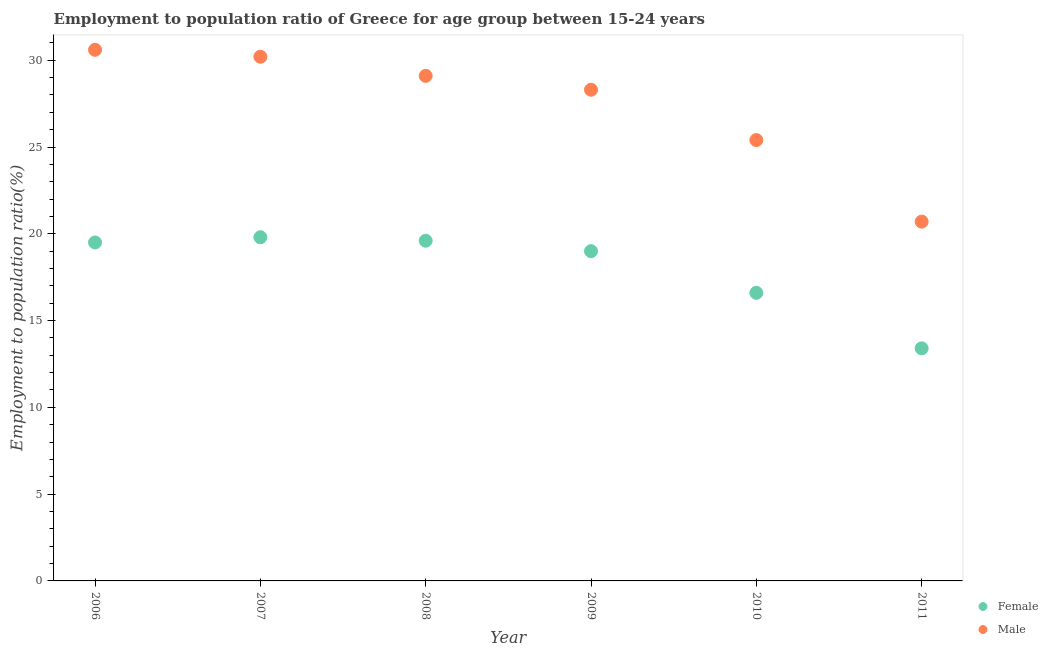What is the employment to population ratio(female) in 2011?
Your answer should be compact. 13.4. Across all years, what is the maximum employment to population ratio(female)?
Give a very brief answer. 19.8. Across all years, what is the minimum employment to population ratio(female)?
Your answer should be very brief. 13.4. What is the total employment to population ratio(female) in the graph?
Provide a short and direct response. 107.9. What is the difference between the employment to population ratio(female) in 2007 and the employment to population ratio(male) in 2010?
Provide a short and direct response. -5.6. What is the average employment to population ratio(female) per year?
Keep it short and to the point. 17.98. In the year 2010, what is the difference between the employment to population ratio(female) and employment to population ratio(male)?
Offer a terse response. -8.8. What is the ratio of the employment to population ratio(male) in 2008 to that in 2011?
Provide a short and direct response. 1.41. Is the difference between the employment to population ratio(female) in 2009 and 2011 greater than the difference between the employment to population ratio(male) in 2009 and 2011?
Keep it short and to the point. No. What is the difference between the highest and the second highest employment to population ratio(male)?
Provide a short and direct response. 0.4. What is the difference between the highest and the lowest employment to population ratio(male)?
Ensure brevity in your answer.  9.9. Is the sum of the employment to population ratio(female) in 2007 and 2010 greater than the maximum employment to population ratio(male) across all years?
Ensure brevity in your answer.  Yes. Is the employment to population ratio(female) strictly greater than the employment to population ratio(male) over the years?
Provide a short and direct response. No. Is the employment to population ratio(male) strictly less than the employment to population ratio(female) over the years?
Give a very brief answer. No. How many dotlines are there?
Your answer should be compact. 2. How many years are there in the graph?
Provide a succinct answer. 6. Are the values on the major ticks of Y-axis written in scientific E-notation?
Your answer should be very brief. No. Where does the legend appear in the graph?
Provide a succinct answer. Bottom right. How many legend labels are there?
Your answer should be compact. 2. How are the legend labels stacked?
Offer a very short reply. Vertical. What is the title of the graph?
Make the answer very short. Employment to population ratio of Greece for age group between 15-24 years. Does "Malaria" appear as one of the legend labels in the graph?
Offer a very short reply. No. What is the Employment to population ratio(%) of Female in 2006?
Your response must be concise. 19.5. What is the Employment to population ratio(%) in Male in 2006?
Your answer should be compact. 30.6. What is the Employment to population ratio(%) in Female in 2007?
Offer a very short reply. 19.8. What is the Employment to population ratio(%) of Male in 2007?
Make the answer very short. 30.2. What is the Employment to population ratio(%) of Female in 2008?
Provide a succinct answer. 19.6. What is the Employment to population ratio(%) of Male in 2008?
Your response must be concise. 29.1. What is the Employment to population ratio(%) in Female in 2009?
Your response must be concise. 19. What is the Employment to population ratio(%) in Male in 2009?
Make the answer very short. 28.3. What is the Employment to population ratio(%) of Female in 2010?
Offer a terse response. 16.6. What is the Employment to population ratio(%) of Male in 2010?
Offer a very short reply. 25.4. What is the Employment to population ratio(%) of Female in 2011?
Offer a very short reply. 13.4. What is the Employment to population ratio(%) in Male in 2011?
Offer a terse response. 20.7. Across all years, what is the maximum Employment to population ratio(%) in Female?
Provide a short and direct response. 19.8. Across all years, what is the maximum Employment to population ratio(%) of Male?
Give a very brief answer. 30.6. Across all years, what is the minimum Employment to population ratio(%) in Female?
Your answer should be very brief. 13.4. Across all years, what is the minimum Employment to population ratio(%) of Male?
Your answer should be compact. 20.7. What is the total Employment to population ratio(%) of Female in the graph?
Give a very brief answer. 107.9. What is the total Employment to population ratio(%) in Male in the graph?
Provide a succinct answer. 164.3. What is the difference between the Employment to population ratio(%) of Female in 2006 and that in 2007?
Your answer should be very brief. -0.3. What is the difference between the Employment to population ratio(%) in Female in 2006 and that in 2008?
Keep it short and to the point. -0.1. What is the difference between the Employment to population ratio(%) in Male in 2006 and that in 2010?
Offer a terse response. 5.2. What is the difference between the Employment to population ratio(%) of Male in 2006 and that in 2011?
Your answer should be very brief. 9.9. What is the difference between the Employment to population ratio(%) in Female in 2007 and that in 2010?
Your answer should be very brief. 3.2. What is the difference between the Employment to population ratio(%) of Female in 2007 and that in 2011?
Keep it short and to the point. 6.4. What is the difference between the Employment to population ratio(%) of Male in 2008 and that in 2010?
Your answer should be very brief. 3.7. What is the difference between the Employment to population ratio(%) in Female in 2008 and that in 2011?
Keep it short and to the point. 6.2. What is the difference between the Employment to population ratio(%) in Female in 2009 and that in 2010?
Your answer should be very brief. 2.4. What is the difference between the Employment to population ratio(%) in Male in 2009 and that in 2010?
Make the answer very short. 2.9. What is the difference between the Employment to population ratio(%) of Male in 2009 and that in 2011?
Your response must be concise. 7.6. What is the difference between the Employment to population ratio(%) in Female in 2006 and the Employment to population ratio(%) in Male in 2009?
Offer a terse response. -8.8. What is the difference between the Employment to population ratio(%) of Female in 2006 and the Employment to population ratio(%) of Male in 2011?
Offer a terse response. -1.2. What is the difference between the Employment to population ratio(%) in Female in 2007 and the Employment to population ratio(%) in Male in 2010?
Make the answer very short. -5.6. What is the difference between the Employment to population ratio(%) in Female in 2007 and the Employment to population ratio(%) in Male in 2011?
Offer a very short reply. -0.9. What is the difference between the Employment to population ratio(%) in Female in 2008 and the Employment to population ratio(%) in Male in 2009?
Your answer should be compact. -8.7. What is the difference between the Employment to population ratio(%) of Female in 2008 and the Employment to population ratio(%) of Male in 2011?
Provide a succinct answer. -1.1. What is the difference between the Employment to population ratio(%) in Female in 2009 and the Employment to population ratio(%) in Male in 2011?
Your answer should be compact. -1.7. What is the difference between the Employment to population ratio(%) in Female in 2010 and the Employment to population ratio(%) in Male in 2011?
Ensure brevity in your answer.  -4.1. What is the average Employment to population ratio(%) of Female per year?
Your answer should be compact. 17.98. What is the average Employment to population ratio(%) of Male per year?
Provide a succinct answer. 27.38. In the year 2006, what is the difference between the Employment to population ratio(%) of Female and Employment to population ratio(%) of Male?
Provide a succinct answer. -11.1. In the year 2007, what is the difference between the Employment to population ratio(%) in Female and Employment to population ratio(%) in Male?
Your answer should be very brief. -10.4. In the year 2008, what is the difference between the Employment to population ratio(%) in Female and Employment to population ratio(%) in Male?
Provide a succinct answer. -9.5. In the year 2009, what is the difference between the Employment to population ratio(%) of Female and Employment to population ratio(%) of Male?
Ensure brevity in your answer.  -9.3. In the year 2011, what is the difference between the Employment to population ratio(%) in Female and Employment to population ratio(%) in Male?
Your response must be concise. -7.3. What is the ratio of the Employment to population ratio(%) of Male in 2006 to that in 2007?
Provide a short and direct response. 1.01. What is the ratio of the Employment to population ratio(%) in Female in 2006 to that in 2008?
Give a very brief answer. 0.99. What is the ratio of the Employment to population ratio(%) in Male in 2006 to that in 2008?
Offer a very short reply. 1.05. What is the ratio of the Employment to population ratio(%) of Female in 2006 to that in 2009?
Your answer should be compact. 1.03. What is the ratio of the Employment to population ratio(%) in Male in 2006 to that in 2009?
Make the answer very short. 1.08. What is the ratio of the Employment to population ratio(%) of Female in 2006 to that in 2010?
Your answer should be very brief. 1.17. What is the ratio of the Employment to population ratio(%) in Male in 2006 to that in 2010?
Offer a terse response. 1.2. What is the ratio of the Employment to population ratio(%) in Female in 2006 to that in 2011?
Provide a succinct answer. 1.46. What is the ratio of the Employment to population ratio(%) of Male in 2006 to that in 2011?
Your answer should be compact. 1.48. What is the ratio of the Employment to population ratio(%) in Female in 2007 to that in 2008?
Your response must be concise. 1.01. What is the ratio of the Employment to population ratio(%) in Male in 2007 to that in 2008?
Provide a succinct answer. 1.04. What is the ratio of the Employment to population ratio(%) in Female in 2007 to that in 2009?
Keep it short and to the point. 1.04. What is the ratio of the Employment to population ratio(%) of Male in 2007 to that in 2009?
Provide a short and direct response. 1.07. What is the ratio of the Employment to population ratio(%) of Female in 2007 to that in 2010?
Your answer should be compact. 1.19. What is the ratio of the Employment to population ratio(%) in Male in 2007 to that in 2010?
Offer a terse response. 1.19. What is the ratio of the Employment to population ratio(%) in Female in 2007 to that in 2011?
Give a very brief answer. 1.48. What is the ratio of the Employment to population ratio(%) in Male in 2007 to that in 2011?
Your response must be concise. 1.46. What is the ratio of the Employment to population ratio(%) of Female in 2008 to that in 2009?
Give a very brief answer. 1.03. What is the ratio of the Employment to population ratio(%) in Male in 2008 to that in 2009?
Your answer should be compact. 1.03. What is the ratio of the Employment to population ratio(%) in Female in 2008 to that in 2010?
Your answer should be compact. 1.18. What is the ratio of the Employment to population ratio(%) in Male in 2008 to that in 2010?
Make the answer very short. 1.15. What is the ratio of the Employment to population ratio(%) in Female in 2008 to that in 2011?
Provide a short and direct response. 1.46. What is the ratio of the Employment to population ratio(%) in Male in 2008 to that in 2011?
Your answer should be very brief. 1.41. What is the ratio of the Employment to population ratio(%) of Female in 2009 to that in 2010?
Keep it short and to the point. 1.14. What is the ratio of the Employment to population ratio(%) of Male in 2009 to that in 2010?
Keep it short and to the point. 1.11. What is the ratio of the Employment to population ratio(%) in Female in 2009 to that in 2011?
Keep it short and to the point. 1.42. What is the ratio of the Employment to population ratio(%) in Male in 2009 to that in 2011?
Provide a short and direct response. 1.37. What is the ratio of the Employment to population ratio(%) of Female in 2010 to that in 2011?
Your response must be concise. 1.24. What is the ratio of the Employment to population ratio(%) of Male in 2010 to that in 2011?
Your response must be concise. 1.23. What is the difference between the highest and the second highest Employment to population ratio(%) in Female?
Your response must be concise. 0.2. 